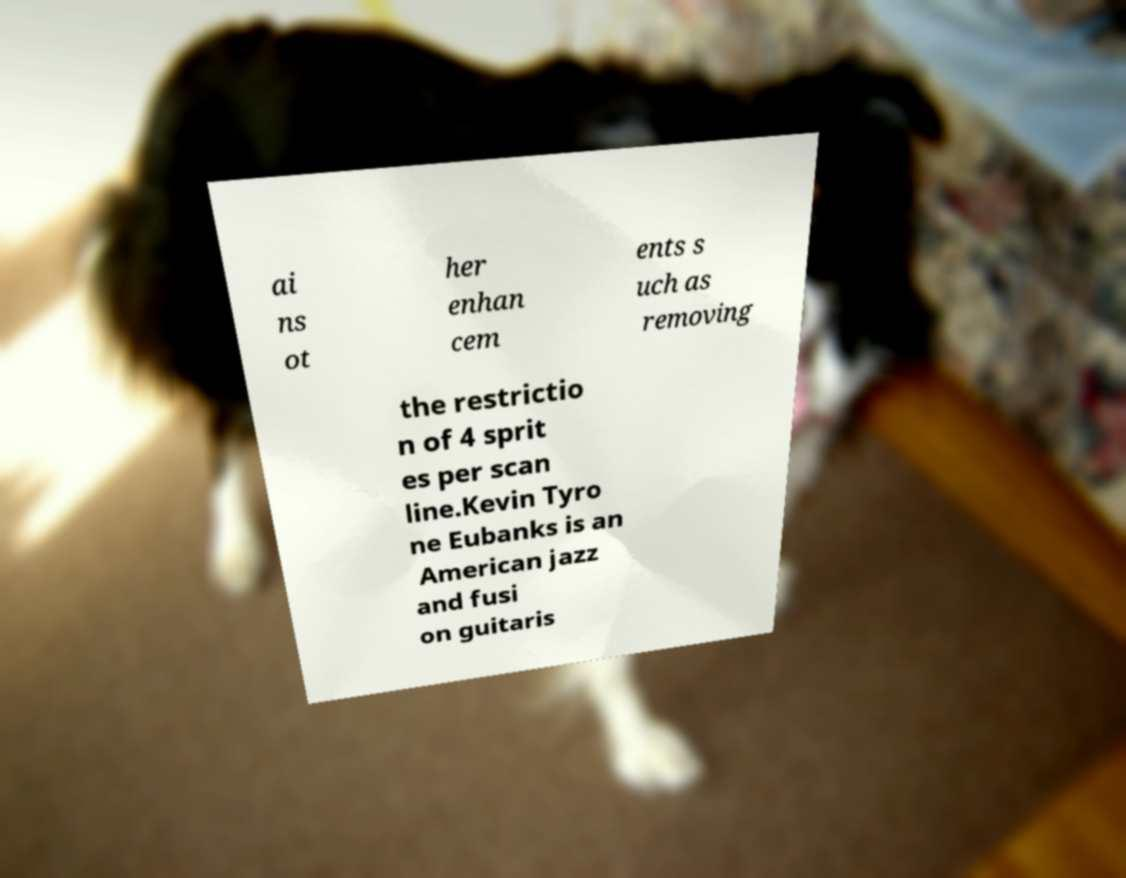I need the written content from this picture converted into text. Can you do that? ai ns ot her enhan cem ents s uch as removing the restrictio n of 4 sprit es per scan line.Kevin Tyro ne Eubanks is an American jazz and fusi on guitaris 